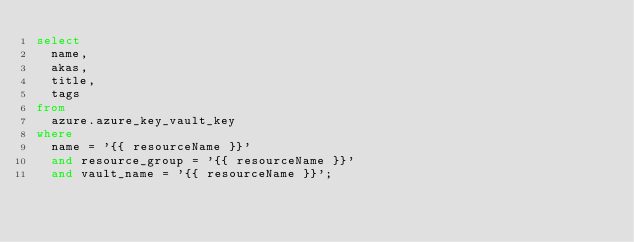<code> <loc_0><loc_0><loc_500><loc_500><_SQL_>select 
  name, 
  akas, 
  title, 
  tags
from 
  azure.azure_key_vault_key
where 
  name = '{{ resourceName }}' 
  and resource_group = '{{ resourceName }}' 
  and vault_name = '{{ resourceName }}';
</code> 